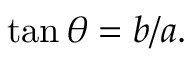<formula> <loc_0><loc_0><loc_500><loc_500>\tan \theta = b / a .</formula> 